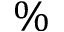<formula> <loc_0><loc_0><loc_500><loc_500>\%</formula> 